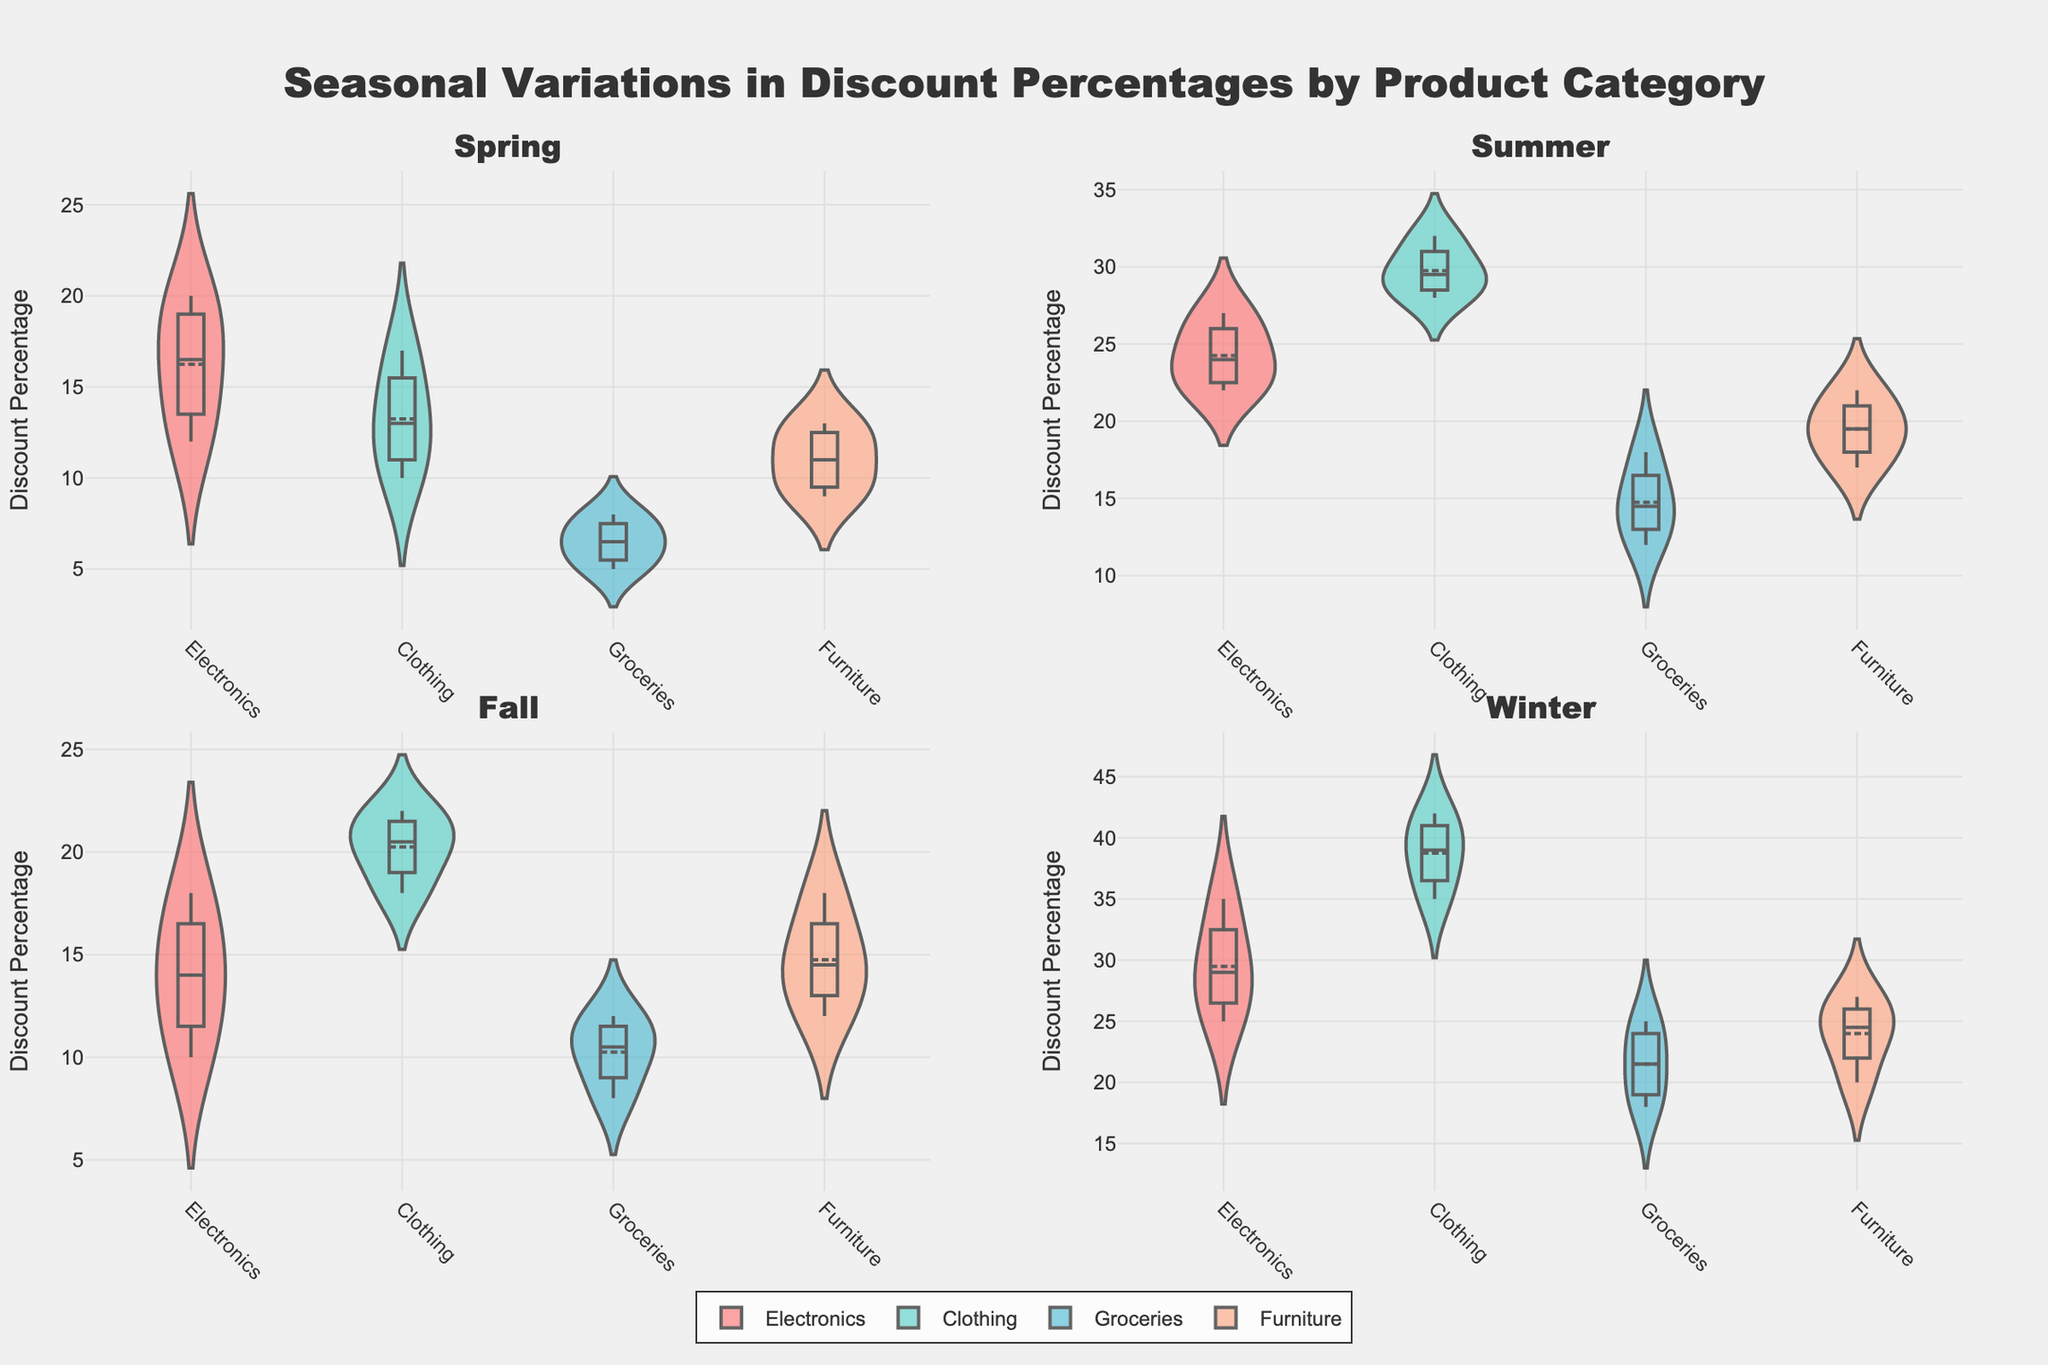What is the title of the figure? The title is located at the top center of the figure and is written in large, bold font. It reads, "Seasonal Variations in Discount Percentages by Product Category".
Answer: Seasonal Variations in Discount Percentages by Product Category What is the average discount percentage for Electronics in Winter? From the Winter subplot, find the Electronics violin plot and observe the mean line. The mean line is around 30%.
Answer: 30% Which product category has the highest average discount percentage in Summer? Examine the Summer subplot, focus on the mean lines of all categories. The Clothing category has the highest mean line, indicating the highest average discount.
Answer: Clothing What is the range of discount percentages for Groceries in Fall? Identify the Groceries violin plot in the Fall subplot. The range is the difference between the maximum and minimum values indicated on the y-axis. Groceries range from 8% to 12%.
Answer: 8%-12% Are the discounts for Furniture more consistent in Spring or Winter? Consistency in discount percentages can be assessed by looking at the width of the violin plots. Narrower plots indicate more consistent discounts. For Furniture, the Winter plot is narrower compared to Spring.
Answer: Winter Which season shows the highest variability in Clothing discounts? Variability in discounts is indicated by the width of the violin plots. Compare the Clothing violin plots across all seasons (Spring, Summer, Fall, Winter). Winter shows the widest plot, indicating highest variability.
Answer: Winter What is the typical discount percentage for Electronics during Fall? The typical discount can be inferred from the central tendency (mean line) of the Electronics violin plot in Fall. The mean line is around 14%.
Answer: 14% How do the discount percentages for Furniture in Summer compare to those in Fall? Compare the mean lines of the Furniture violin plots in both Summer and Fall subplots. In Summer, the mean is around 19.5%, while in Fall it is approximately 14.5%. Thus, Summer has higher discounts.
Answer: Higher in Summer What is the median discount percentage for Groceries in Winter? The median is typically represented by the thick line in the middle of the violin plot. For Groceries in Winter, the median line appears to be at around 22%.
Answer: 22% Which product category has the lowest average discount in Spring? Look at the mean lines of all product categories in the Spring subplot. Groceries have the lowest mean discount percentage.
Answer: Groceries 